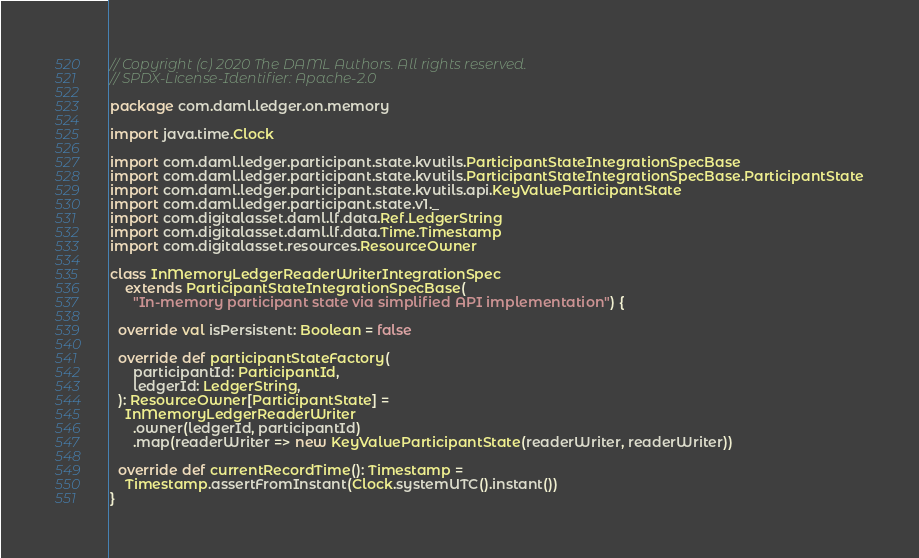<code> <loc_0><loc_0><loc_500><loc_500><_Scala_>// Copyright (c) 2020 The DAML Authors. All rights reserved.
// SPDX-License-Identifier: Apache-2.0

package com.daml.ledger.on.memory

import java.time.Clock

import com.daml.ledger.participant.state.kvutils.ParticipantStateIntegrationSpecBase
import com.daml.ledger.participant.state.kvutils.ParticipantStateIntegrationSpecBase.ParticipantState
import com.daml.ledger.participant.state.kvutils.api.KeyValueParticipantState
import com.daml.ledger.participant.state.v1._
import com.digitalasset.daml.lf.data.Ref.LedgerString
import com.digitalasset.daml.lf.data.Time.Timestamp
import com.digitalasset.resources.ResourceOwner

class InMemoryLedgerReaderWriterIntegrationSpec
    extends ParticipantStateIntegrationSpecBase(
      "In-memory participant state via simplified API implementation") {

  override val isPersistent: Boolean = false

  override def participantStateFactory(
      participantId: ParticipantId,
      ledgerId: LedgerString,
  ): ResourceOwner[ParticipantState] =
    InMemoryLedgerReaderWriter
      .owner(ledgerId, participantId)
      .map(readerWriter => new KeyValueParticipantState(readerWriter, readerWriter))

  override def currentRecordTime(): Timestamp =
    Timestamp.assertFromInstant(Clock.systemUTC().instant())
}
</code> 